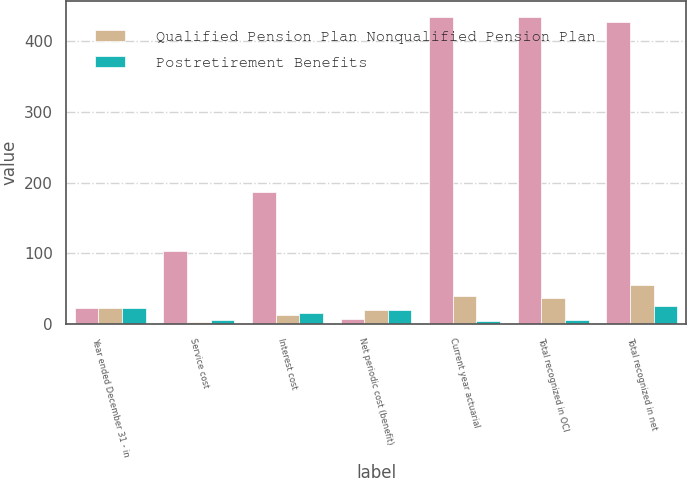<chart> <loc_0><loc_0><loc_500><loc_500><stacked_bar_chart><ecel><fcel>Year ended December 31 - in<fcel>Service cost<fcel>Interest cost<fcel>Net periodic cost (benefit)<fcel>Current year actuarial<fcel>Total recognized in OCI<fcel>Total recognized in net<nl><fcel>nan<fcel>22<fcel>103<fcel>187<fcel>7<fcel>434<fcel>435<fcel>428<nl><fcel>Qualified Pension Plan Nonqualified Pension Plan<fcel>22<fcel>3<fcel>12<fcel>19<fcel>40<fcel>36<fcel>55<nl><fcel>Postretirement Benefits<fcel>22<fcel>5<fcel>16<fcel>19<fcel>4<fcel>6<fcel>25<nl></chart> 